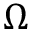<formula> <loc_0><loc_0><loc_500><loc_500>\Omega</formula> 